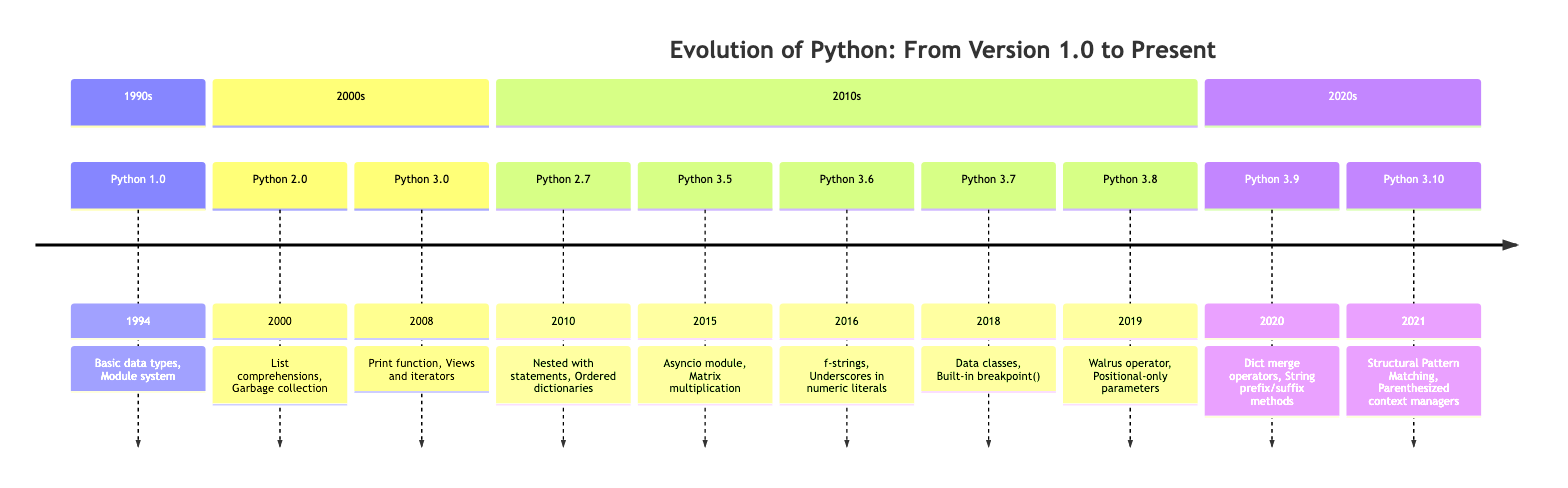What version was released in January 1994? The timeline indicates that Python 1.0 is marked with a release date of January 1994.
Answer: Python 1.0 What key feature was introduced in Python 3.9? The diagram shows that one of the key features introduced in Python 3.9 is the dictionary merge and update operators.
Answer: Dictionary merge and update operators How many major versions are shown in the timeline? By counting the distinct versions listed (Python 1.0, Python 2.0, Python 2.7, Python 3.0, Python 3.5, Python 3.6, Python 3.7, Python 3.8, Python 3.9, Python 3.10), we find there are ten major versions in total.
Answer: Ten What impact did Python 3.0 have on programming practices? The impact of Python 3.0, as indicated in the timeline, was introducing backward-incompatible changes to correct design flaws, which encouraged modernization.
Answer: Introduced backward-incompatible changes Which version introduced the Asyncio module? According to the timeline, Python 3.5 is the version that introduced the Asyncio module.
Answer: Python 3.5 What was notable about the release of Python 2.7 in July 2010? The timeline notes that Python 2.7 marked the final release of the Python 2.x series, providing a transitional path towards Python 3.x.
Answer: Final release of Python 2.x series What is the significance of the year 2015 in the timeline? The significance of the year 2015 in the timeline is that it marks the release of Python 3.5, which introduced both the Asyncio module and the matrix multiplication operator.
Answer: Release of Python 3.5 How many features are listed for Python 3.8? In the timeline, Python 3.8 is associated with two features: the Walrus operator and positional-only parameters. Thus, we see there are two features listed for this version.
Answer: Two Which version introduced f-strings? The diagram shows that f-strings were introduced with Python 3.6.
Answer: Python 3.6 What are the two main features of Python 2.0? For Python 2.0, the timeline indicates that list comprehensions and a garbage collection system capable of collecting reference cycles were the two main features.
Answer: List comprehensions, Garbage collection system 